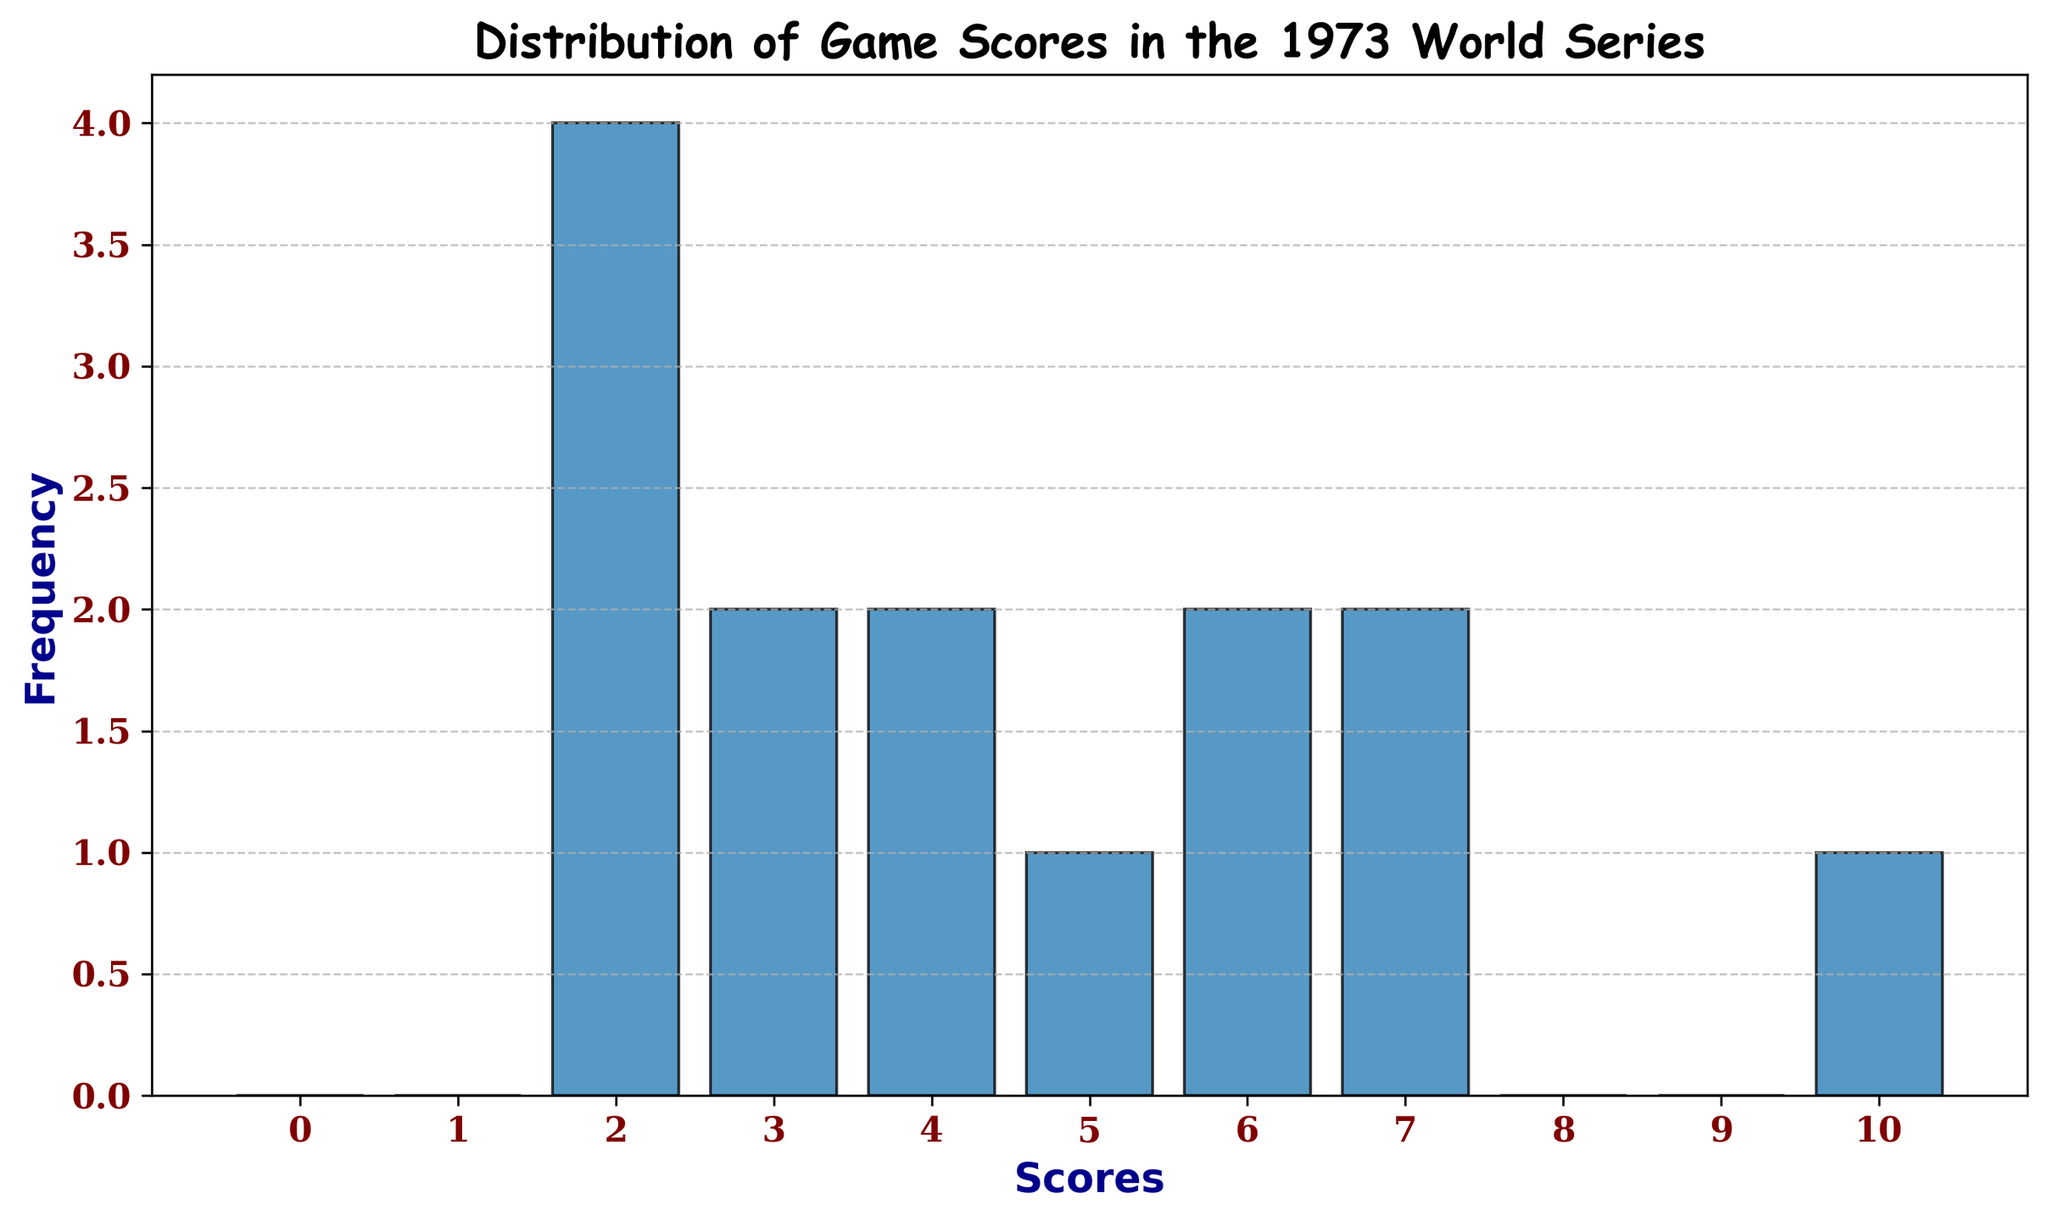What is the most common score in the 1973 World Series? To determine the most common score, look at the bar/column that reaches the highest point on the histogram. This bar represents the score with the highest frequency.
Answer: 2 How many games had a score of 7? Find the bar/column that corresponds to the score of 7 on the x-axis and look at its height to see how many games had that score.
Answer: 2 What is the total number of scores in the histogram? Sum the frequencies of all the bars/columns in the histogram to get the total number of scores. The individual frequencies are 3, 3, 1, 1, 2, 1, 3.
Answer: 14 Which score appears more frequently, 4 or 6? Compare the heights of the bars/columns corresponding to the scores 4 and 6 on the x-axis. The frequency of score 4 is 2, and the frequency of score 6 is 2. They appear equally frequently.
Answer: Equally frequent What's the combined frequency of scores that are less than 3? Look at the bars/columns for scores 0, 1, and 2, and sum their frequencies (0, 0, and 3, respectively).
Answer: 3 What is the rarest score in the histogram? Find the bar/column with the lowest height. Scores with 0 games are 0 and 1, making them the rarest.
Answer: 0 and 1 Which score range has more games: scores less than 5 or scores equal to or greater than 5? Sum the frequencies of bars/columns for scores less than 5 (0, 1, 2, 3, 4) and compare it to the sum of frequencies for scores equal to or greater than 5 (5, 6, 7, 8, 9, 10). Less than 5 sum: 8; 5 or more sum: 6.
Answer: Less than 5 Is there any score that no game achieved? Look for any bar/column with a height of zero, which indicates that no game had that score. The scores 0 and 1 have frequencies of zero, meaning they were not achieved.
Answer: Yes How many games had a score between 3 and 7, inclusive? Sum the frequencies of the bars/columns for scores 3, 4, 5, 6, and 7 (1, 2, 1, 2, and 2 respectively).
Answer: 8 